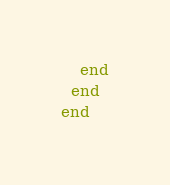<code> <loc_0><loc_0><loc_500><loc_500><_Ruby_>    end
  end
end
</code> 